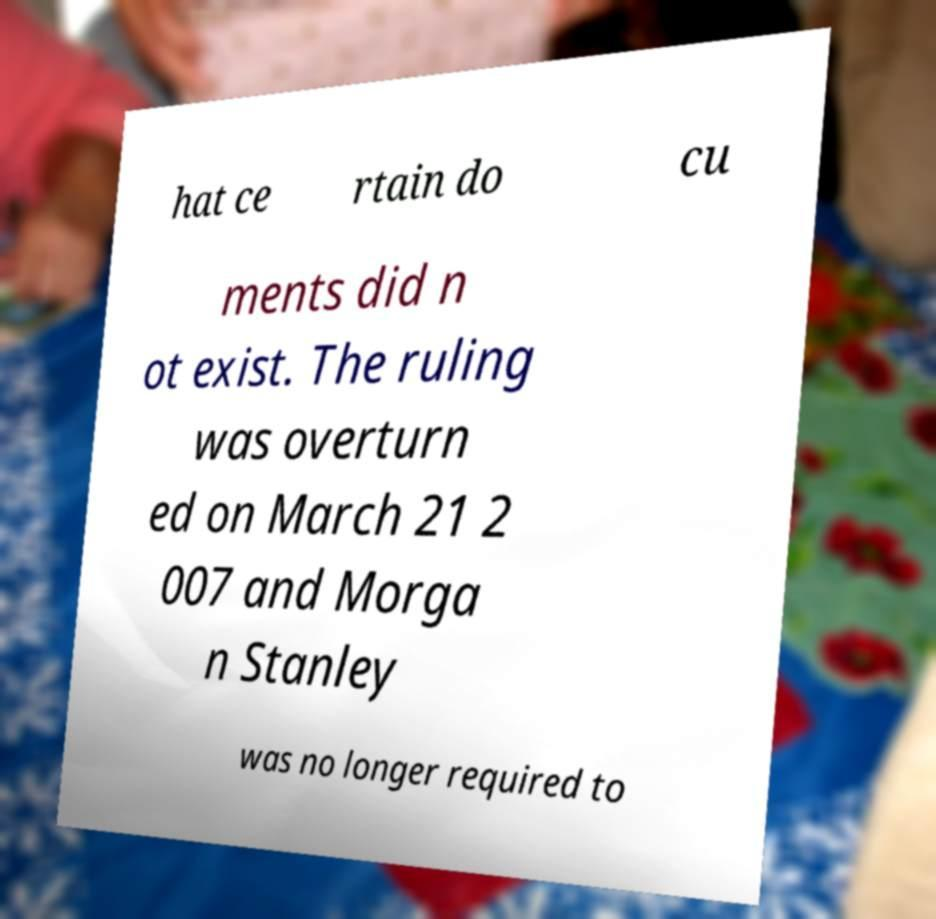There's text embedded in this image that I need extracted. Can you transcribe it verbatim? hat ce rtain do cu ments did n ot exist. The ruling was overturn ed on March 21 2 007 and Morga n Stanley was no longer required to 